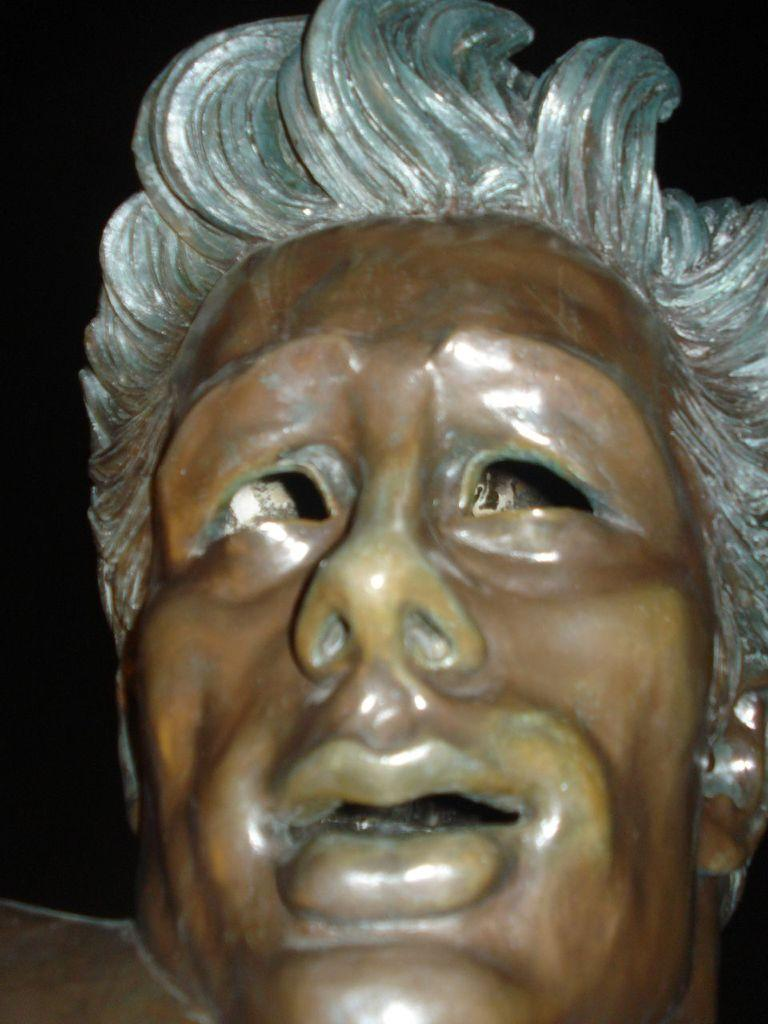What is the main subject of the image? There is a sculpture in the image. What feature does the sculpture have? The sculpture has a face. What is placed on the face of the sculpture? There is a white chair on the face of the sculpture. How does the orange run around the sculpture in the image? There is no orange present in the image, and therefore no such activity can be observed. 